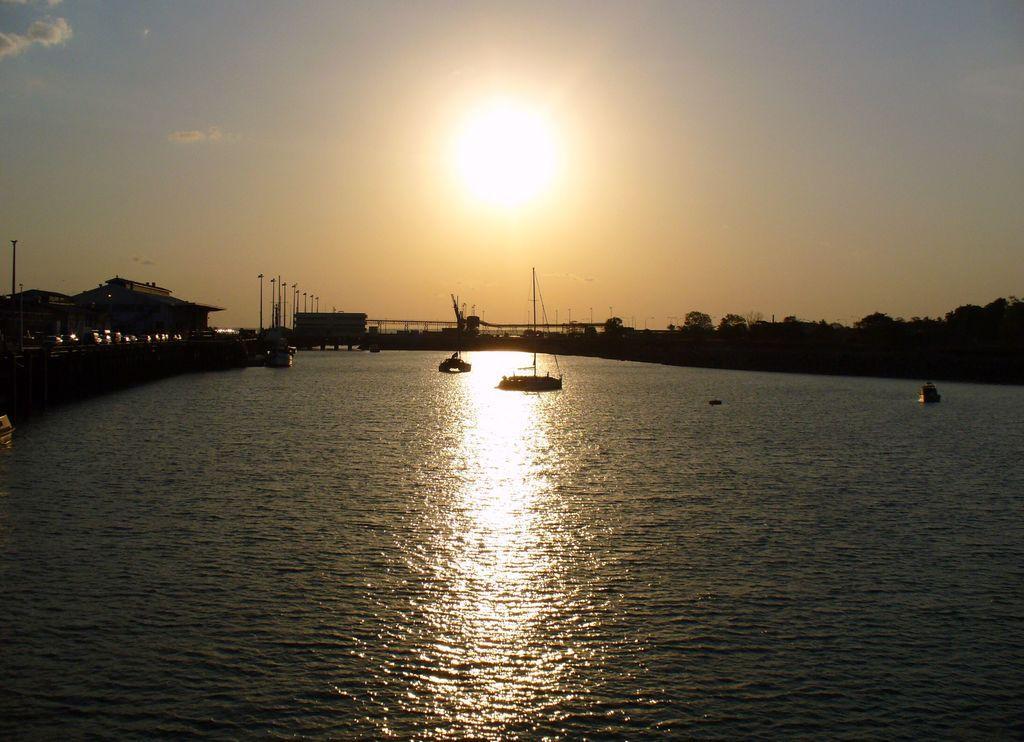Please provide a concise description of this image. In the image I can see boats on the water. In the background I can see buildings, trees, the sky and the sun. 